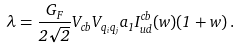<formula> <loc_0><loc_0><loc_500><loc_500>\lambda = \frac { G _ { F } } { 2 \sqrt { 2 } } V _ { c b } V _ { q _ { i } q _ { j } } a _ { 1 } I _ { u d } ^ { c b } ( w ) ( 1 + w ) \, .</formula> 